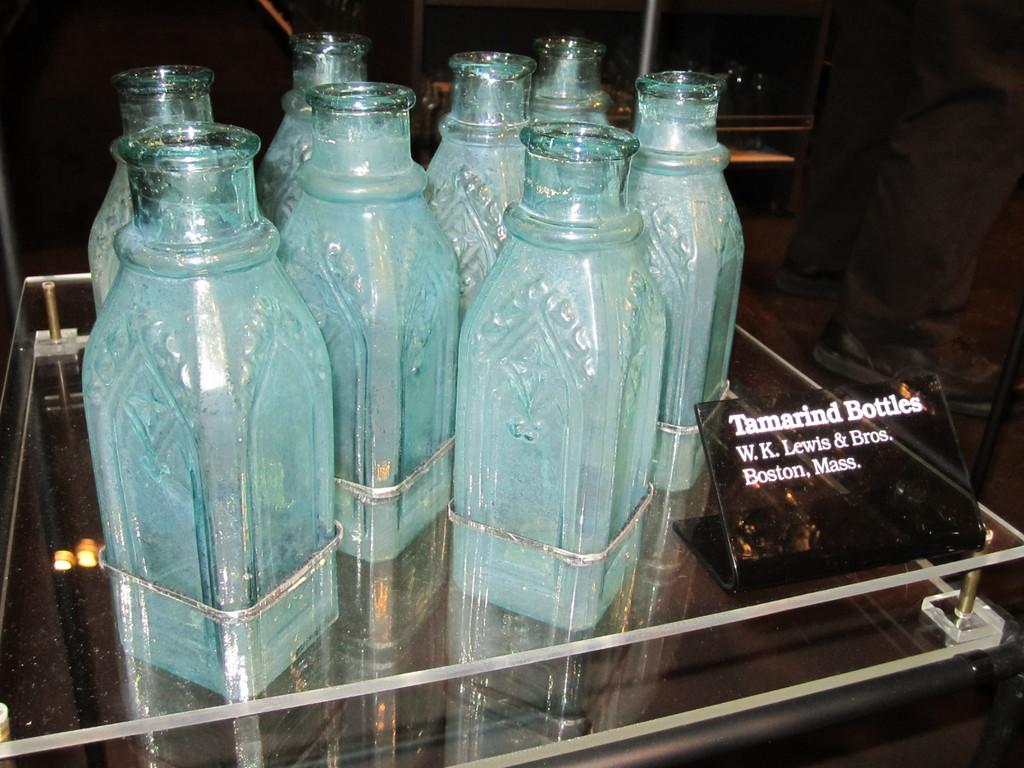What city and state are these bottles from?
Keep it short and to the point. Boston, mass. What kind of bottles?
Your answer should be compact. Tamarind. 